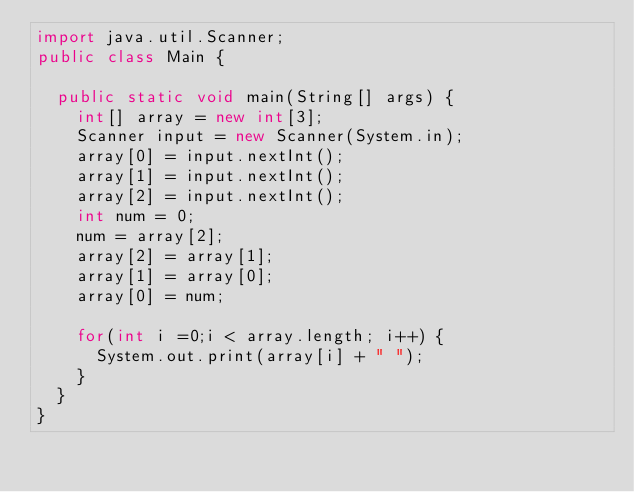<code> <loc_0><loc_0><loc_500><loc_500><_Java_>import java.util.Scanner;
public class Main {

	public static void main(String[] args) {
		int[] array = new int[3];
		Scanner input = new Scanner(System.in);
		array[0] = input.nextInt();
		array[1] = input.nextInt();
		array[2] = input.nextInt();
		int num = 0;
		num = array[2];
		array[2] = array[1];
		array[1] = array[0];
		array[0] = num;
		
		for(int i =0;i < array.length; i++) {
			System.out.print(array[i] + " ");	
		}
	}
}</code> 